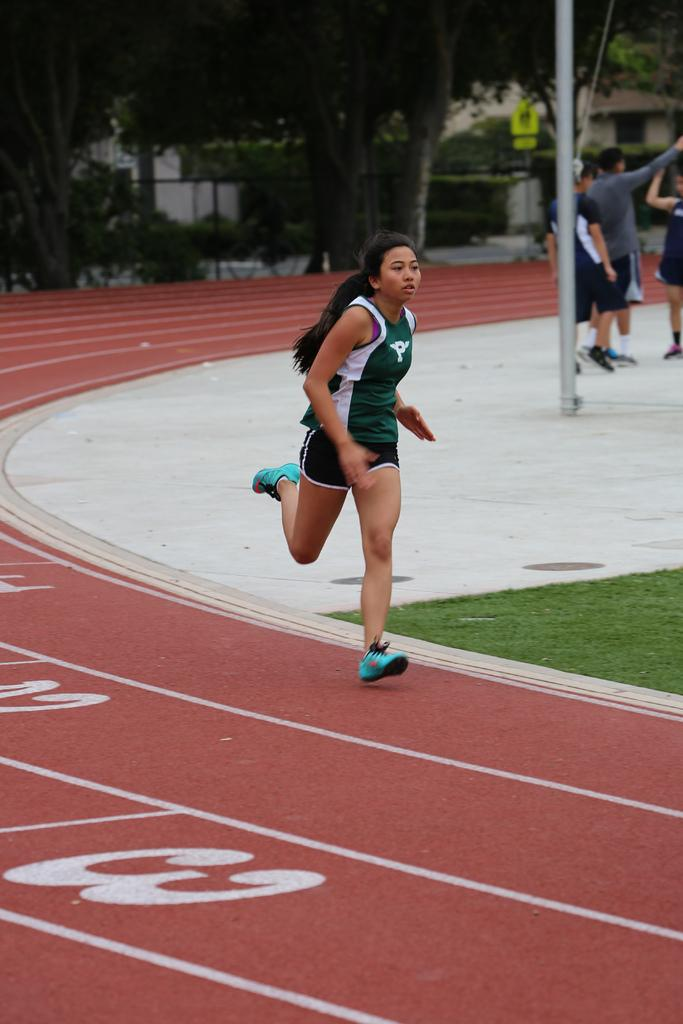<image>
Write a terse but informative summary of the picture. A woman is running on a track and is about to pass the 3 mark. 